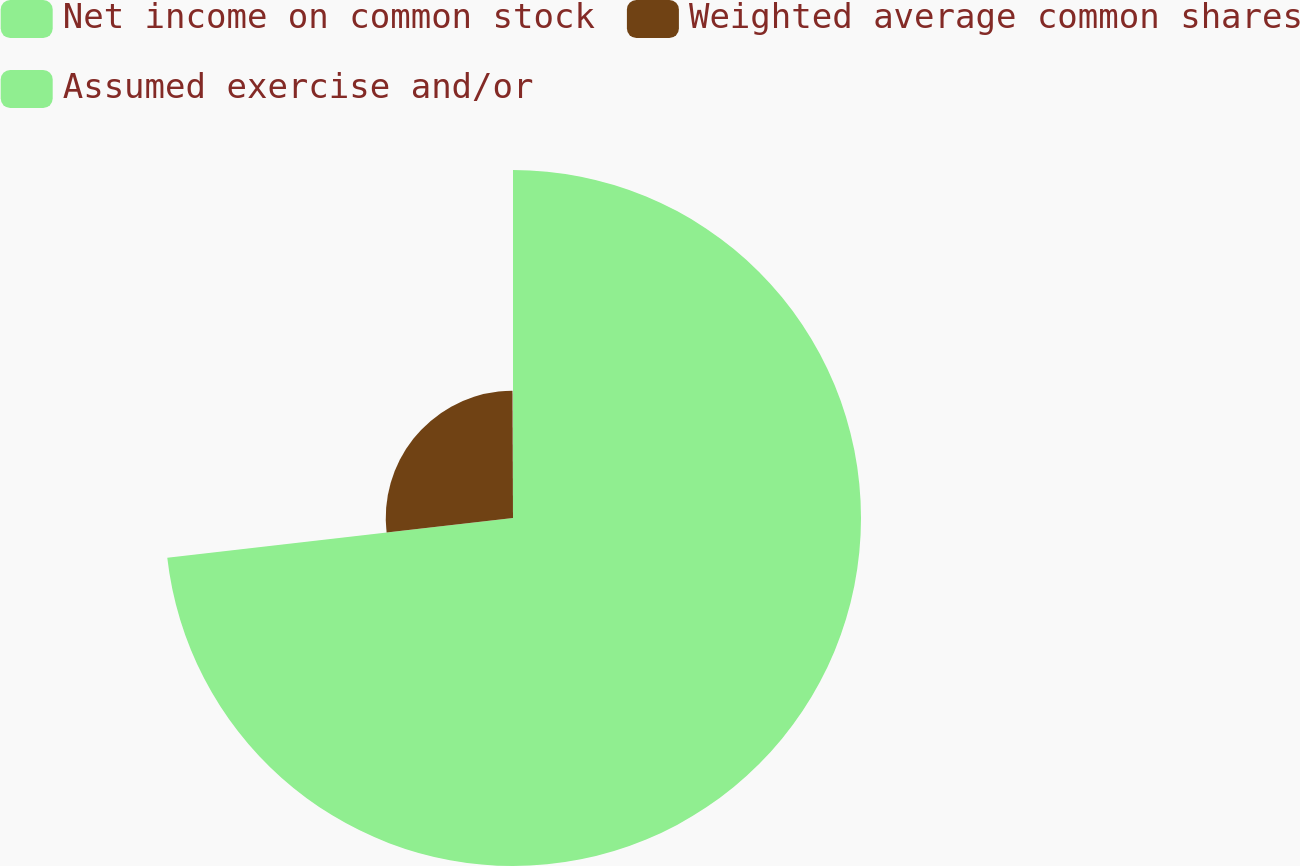Convert chart. <chart><loc_0><loc_0><loc_500><loc_500><pie_chart><fcel>Net income on common stock<fcel>Weighted average common shares<fcel>Assumed exercise and/or<nl><fcel>73.18%<fcel>26.76%<fcel>0.06%<nl></chart> 